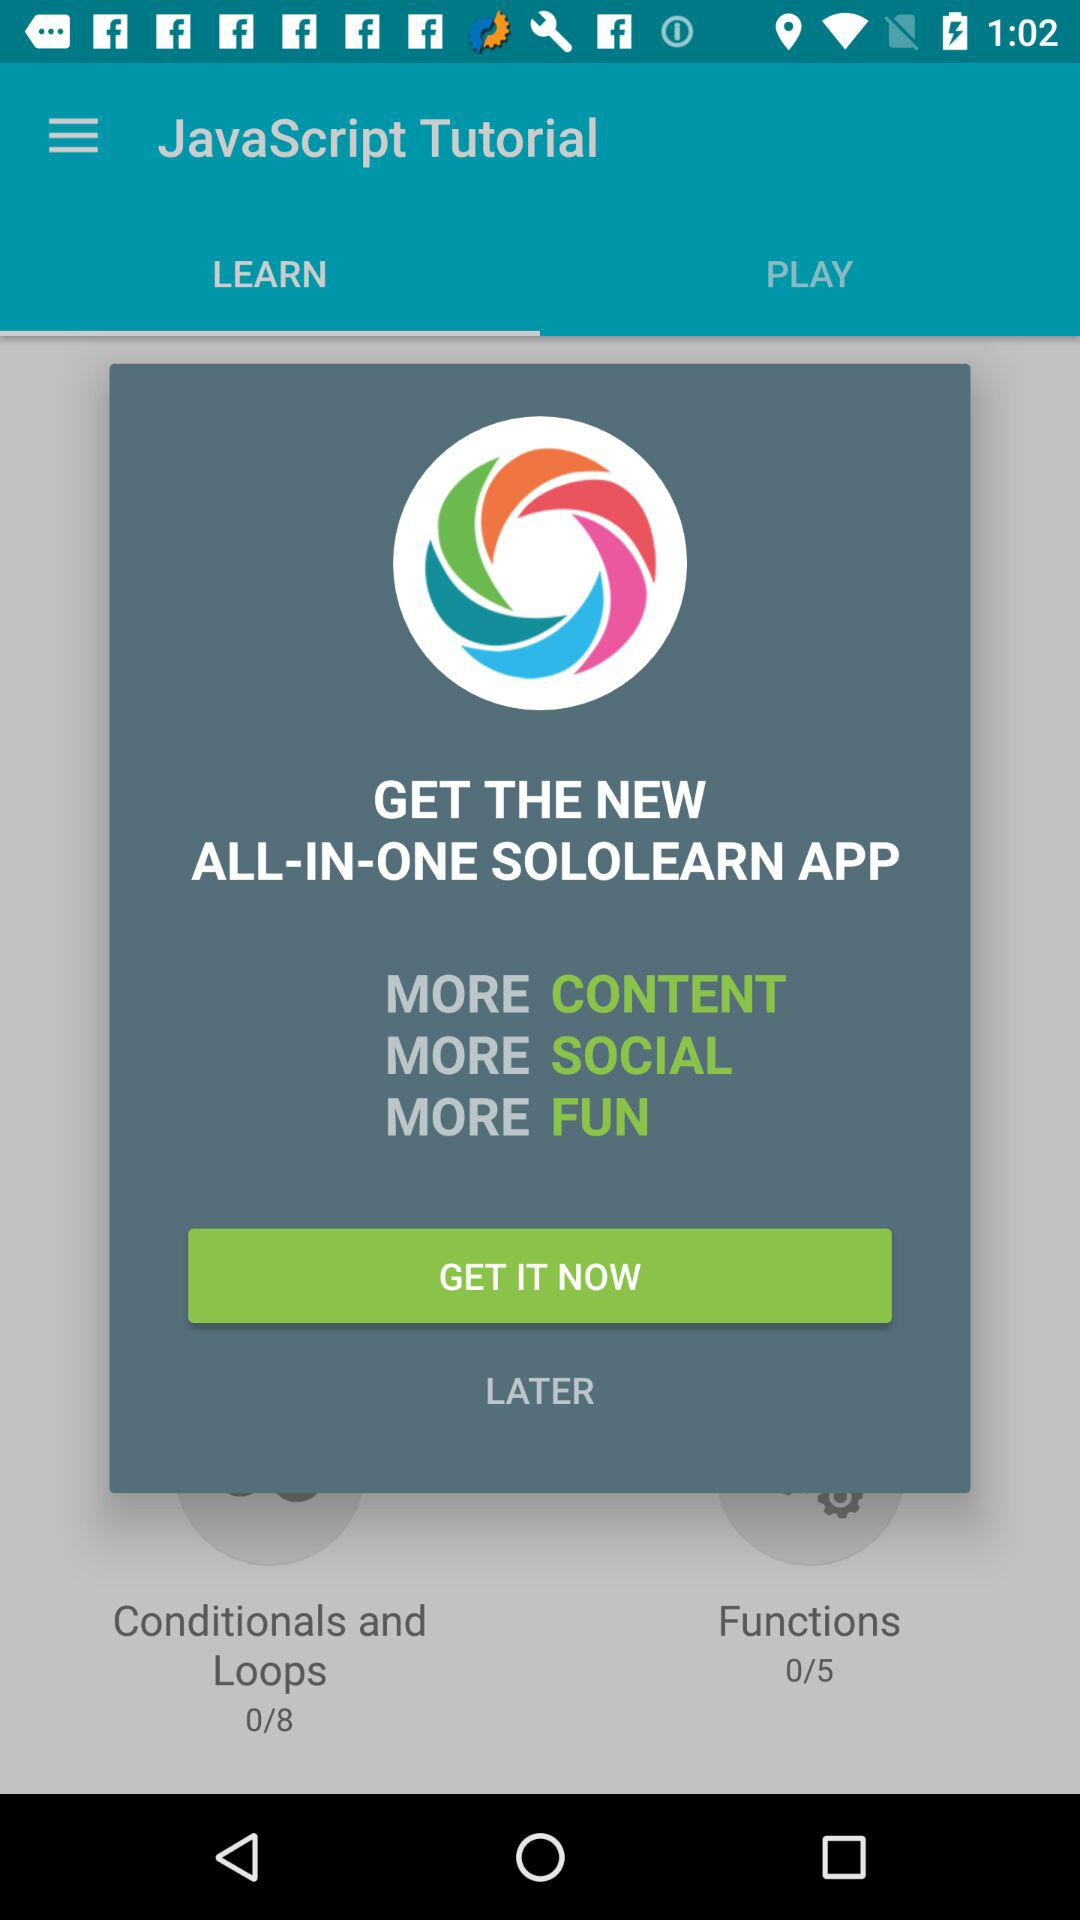What is the selected tab? The selected tab is "LEARN". 